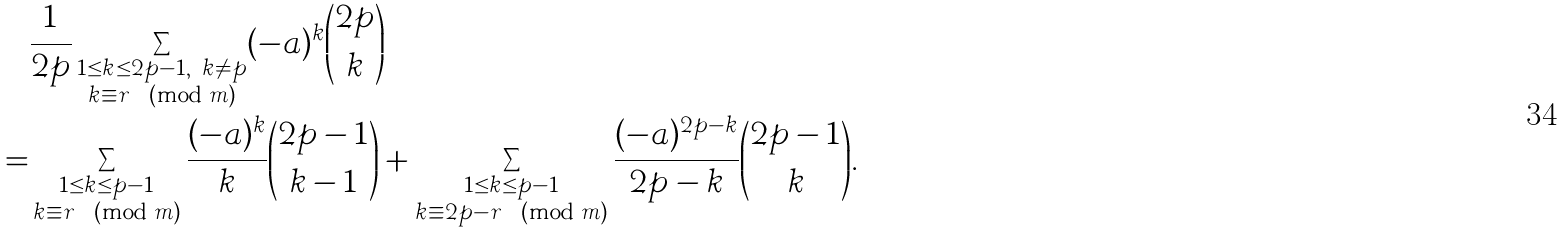<formula> <loc_0><loc_0><loc_500><loc_500>& \frac { 1 } { 2 p } \sum _ { \substack { 1 \leq k \leq 2 p - 1 , \ k \not = p \\ k \equiv r \pmod { m } } } ( - a ) ^ { k } \binom { 2 p } { k } \\ = & \sum _ { \substack { 1 \leq k \leq p - 1 \\ k \equiv r \pmod { m } } } \frac { ( - a ) ^ { k } } { k } \binom { 2 p - 1 } { k - 1 } + \sum _ { \substack { 1 \leq k \leq p - 1 \\ k \equiv 2 p - r \pmod { m } } } \frac { ( - a ) ^ { 2 p - k } } { 2 p - k } \binom { 2 p - 1 } { k } .</formula> 